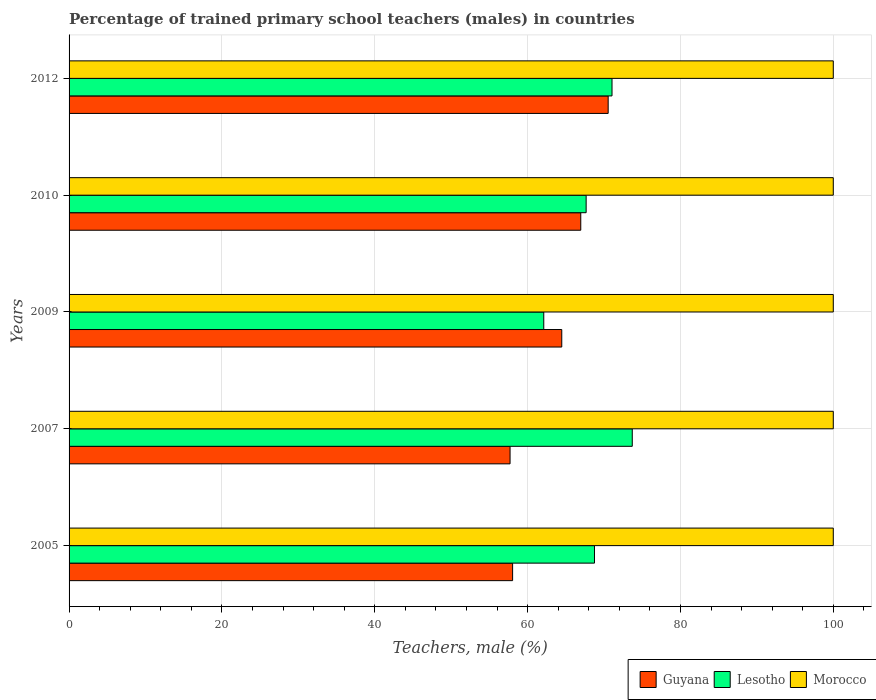How many groups of bars are there?
Give a very brief answer. 5. Are the number of bars per tick equal to the number of legend labels?
Your answer should be compact. Yes. What is the label of the 4th group of bars from the top?
Provide a succinct answer. 2007. In which year was the percentage of trained primary school teachers (males) in Morocco maximum?
Your answer should be very brief. 2005. What is the total percentage of trained primary school teachers (males) in Lesotho in the graph?
Your answer should be compact. 343.27. What is the difference between the percentage of trained primary school teachers (males) in Lesotho in 2005 and that in 2012?
Offer a very short reply. -2.29. What is the difference between the percentage of trained primary school teachers (males) in Guyana in 2010 and the percentage of trained primary school teachers (males) in Lesotho in 2009?
Your answer should be compact. 4.84. What is the average percentage of trained primary school teachers (males) in Lesotho per year?
Provide a short and direct response. 68.65. In the year 2009, what is the difference between the percentage of trained primary school teachers (males) in Morocco and percentage of trained primary school teachers (males) in Lesotho?
Your response must be concise. 37.88. What is the ratio of the percentage of trained primary school teachers (males) in Lesotho in 2007 to that in 2012?
Your answer should be very brief. 1.04. What is the difference between the highest and the second highest percentage of trained primary school teachers (males) in Guyana?
Give a very brief answer. 3.59. What is the difference between the highest and the lowest percentage of trained primary school teachers (males) in Guyana?
Give a very brief answer. 12.84. In how many years, is the percentage of trained primary school teachers (males) in Lesotho greater than the average percentage of trained primary school teachers (males) in Lesotho taken over all years?
Provide a short and direct response. 3. Is the sum of the percentage of trained primary school teachers (males) in Morocco in 2005 and 2012 greater than the maximum percentage of trained primary school teachers (males) in Guyana across all years?
Keep it short and to the point. Yes. What does the 1st bar from the top in 2007 represents?
Make the answer very short. Morocco. What does the 2nd bar from the bottom in 2010 represents?
Your answer should be very brief. Lesotho. Are all the bars in the graph horizontal?
Give a very brief answer. Yes. How many years are there in the graph?
Your answer should be very brief. 5. Does the graph contain any zero values?
Make the answer very short. No. How are the legend labels stacked?
Your answer should be very brief. Horizontal. What is the title of the graph?
Offer a terse response. Percentage of trained primary school teachers (males) in countries. What is the label or title of the X-axis?
Your answer should be compact. Teachers, male (%). What is the Teachers, male (%) in Guyana in 2005?
Offer a terse response. 58.04. What is the Teachers, male (%) in Lesotho in 2005?
Give a very brief answer. 68.75. What is the Teachers, male (%) in Morocco in 2005?
Your answer should be compact. 100. What is the Teachers, male (%) in Guyana in 2007?
Offer a terse response. 57.71. What is the Teachers, male (%) in Lesotho in 2007?
Ensure brevity in your answer.  73.7. What is the Teachers, male (%) of Guyana in 2009?
Offer a very short reply. 64.47. What is the Teachers, male (%) of Lesotho in 2009?
Ensure brevity in your answer.  62.12. What is the Teachers, male (%) of Guyana in 2010?
Your answer should be compact. 66.96. What is the Teachers, male (%) in Lesotho in 2010?
Make the answer very short. 67.66. What is the Teachers, male (%) of Guyana in 2012?
Provide a succinct answer. 70.54. What is the Teachers, male (%) of Lesotho in 2012?
Offer a very short reply. 71.05. Across all years, what is the maximum Teachers, male (%) in Guyana?
Provide a short and direct response. 70.54. Across all years, what is the maximum Teachers, male (%) in Lesotho?
Offer a very short reply. 73.7. Across all years, what is the minimum Teachers, male (%) in Guyana?
Your response must be concise. 57.71. Across all years, what is the minimum Teachers, male (%) in Lesotho?
Provide a succinct answer. 62.12. What is the total Teachers, male (%) in Guyana in the graph?
Your answer should be compact. 317.71. What is the total Teachers, male (%) in Lesotho in the graph?
Give a very brief answer. 343.27. What is the difference between the Teachers, male (%) of Guyana in 2005 and that in 2007?
Your response must be concise. 0.33. What is the difference between the Teachers, male (%) in Lesotho in 2005 and that in 2007?
Offer a very short reply. -4.94. What is the difference between the Teachers, male (%) of Guyana in 2005 and that in 2009?
Keep it short and to the point. -6.43. What is the difference between the Teachers, male (%) in Lesotho in 2005 and that in 2009?
Offer a very short reply. 6.64. What is the difference between the Teachers, male (%) in Guyana in 2005 and that in 2010?
Keep it short and to the point. -8.92. What is the difference between the Teachers, male (%) in Lesotho in 2005 and that in 2010?
Give a very brief answer. 1.09. What is the difference between the Teachers, male (%) of Morocco in 2005 and that in 2010?
Ensure brevity in your answer.  0. What is the difference between the Teachers, male (%) of Guyana in 2005 and that in 2012?
Keep it short and to the point. -12.5. What is the difference between the Teachers, male (%) of Lesotho in 2005 and that in 2012?
Give a very brief answer. -2.29. What is the difference between the Teachers, male (%) in Guyana in 2007 and that in 2009?
Offer a terse response. -6.76. What is the difference between the Teachers, male (%) of Lesotho in 2007 and that in 2009?
Offer a terse response. 11.58. What is the difference between the Teachers, male (%) in Morocco in 2007 and that in 2009?
Your response must be concise. 0. What is the difference between the Teachers, male (%) of Guyana in 2007 and that in 2010?
Make the answer very short. -9.25. What is the difference between the Teachers, male (%) in Lesotho in 2007 and that in 2010?
Provide a short and direct response. 6.04. What is the difference between the Teachers, male (%) of Morocco in 2007 and that in 2010?
Provide a short and direct response. 0. What is the difference between the Teachers, male (%) in Guyana in 2007 and that in 2012?
Ensure brevity in your answer.  -12.84. What is the difference between the Teachers, male (%) in Lesotho in 2007 and that in 2012?
Provide a short and direct response. 2.65. What is the difference between the Teachers, male (%) in Guyana in 2009 and that in 2010?
Make the answer very short. -2.49. What is the difference between the Teachers, male (%) in Lesotho in 2009 and that in 2010?
Provide a succinct answer. -5.54. What is the difference between the Teachers, male (%) of Morocco in 2009 and that in 2010?
Offer a very short reply. 0. What is the difference between the Teachers, male (%) in Guyana in 2009 and that in 2012?
Give a very brief answer. -6.07. What is the difference between the Teachers, male (%) of Lesotho in 2009 and that in 2012?
Give a very brief answer. -8.93. What is the difference between the Teachers, male (%) of Guyana in 2010 and that in 2012?
Your answer should be very brief. -3.59. What is the difference between the Teachers, male (%) of Lesotho in 2010 and that in 2012?
Give a very brief answer. -3.38. What is the difference between the Teachers, male (%) of Morocco in 2010 and that in 2012?
Your answer should be very brief. 0. What is the difference between the Teachers, male (%) of Guyana in 2005 and the Teachers, male (%) of Lesotho in 2007?
Provide a short and direct response. -15.66. What is the difference between the Teachers, male (%) in Guyana in 2005 and the Teachers, male (%) in Morocco in 2007?
Provide a short and direct response. -41.96. What is the difference between the Teachers, male (%) in Lesotho in 2005 and the Teachers, male (%) in Morocco in 2007?
Offer a terse response. -31.25. What is the difference between the Teachers, male (%) of Guyana in 2005 and the Teachers, male (%) of Lesotho in 2009?
Your answer should be very brief. -4.08. What is the difference between the Teachers, male (%) in Guyana in 2005 and the Teachers, male (%) in Morocco in 2009?
Offer a very short reply. -41.96. What is the difference between the Teachers, male (%) of Lesotho in 2005 and the Teachers, male (%) of Morocco in 2009?
Your response must be concise. -31.25. What is the difference between the Teachers, male (%) of Guyana in 2005 and the Teachers, male (%) of Lesotho in 2010?
Provide a short and direct response. -9.62. What is the difference between the Teachers, male (%) of Guyana in 2005 and the Teachers, male (%) of Morocco in 2010?
Offer a very short reply. -41.96. What is the difference between the Teachers, male (%) in Lesotho in 2005 and the Teachers, male (%) in Morocco in 2010?
Offer a terse response. -31.25. What is the difference between the Teachers, male (%) in Guyana in 2005 and the Teachers, male (%) in Lesotho in 2012?
Offer a terse response. -13.01. What is the difference between the Teachers, male (%) in Guyana in 2005 and the Teachers, male (%) in Morocco in 2012?
Offer a very short reply. -41.96. What is the difference between the Teachers, male (%) of Lesotho in 2005 and the Teachers, male (%) of Morocco in 2012?
Offer a very short reply. -31.25. What is the difference between the Teachers, male (%) in Guyana in 2007 and the Teachers, male (%) in Lesotho in 2009?
Offer a terse response. -4.41. What is the difference between the Teachers, male (%) of Guyana in 2007 and the Teachers, male (%) of Morocco in 2009?
Your response must be concise. -42.29. What is the difference between the Teachers, male (%) of Lesotho in 2007 and the Teachers, male (%) of Morocco in 2009?
Your answer should be very brief. -26.3. What is the difference between the Teachers, male (%) of Guyana in 2007 and the Teachers, male (%) of Lesotho in 2010?
Make the answer very short. -9.96. What is the difference between the Teachers, male (%) in Guyana in 2007 and the Teachers, male (%) in Morocco in 2010?
Your answer should be very brief. -42.29. What is the difference between the Teachers, male (%) of Lesotho in 2007 and the Teachers, male (%) of Morocco in 2010?
Provide a succinct answer. -26.3. What is the difference between the Teachers, male (%) in Guyana in 2007 and the Teachers, male (%) in Lesotho in 2012?
Provide a short and direct response. -13.34. What is the difference between the Teachers, male (%) in Guyana in 2007 and the Teachers, male (%) in Morocco in 2012?
Make the answer very short. -42.29. What is the difference between the Teachers, male (%) in Lesotho in 2007 and the Teachers, male (%) in Morocco in 2012?
Offer a very short reply. -26.3. What is the difference between the Teachers, male (%) in Guyana in 2009 and the Teachers, male (%) in Lesotho in 2010?
Give a very brief answer. -3.19. What is the difference between the Teachers, male (%) in Guyana in 2009 and the Teachers, male (%) in Morocco in 2010?
Give a very brief answer. -35.53. What is the difference between the Teachers, male (%) in Lesotho in 2009 and the Teachers, male (%) in Morocco in 2010?
Offer a terse response. -37.88. What is the difference between the Teachers, male (%) in Guyana in 2009 and the Teachers, male (%) in Lesotho in 2012?
Offer a terse response. -6.57. What is the difference between the Teachers, male (%) in Guyana in 2009 and the Teachers, male (%) in Morocco in 2012?
Provide a short and direct response. -35.53. What is the difference between the Teachers, male (%) in Lesotho in 2009 and the Teachers, male (%) in Morocco in 2012?
Your answer should be compact. -37.88. What is the difference between the Teachers, male (%) of Guyana in 2010 and the Teachers, male (%) of Lesotho in 2012?
Give a very brief answer. -4.09. What is the difference between the Teachers, male (%) in Guyana in 2010 and the Teachers, male (%) in Morocco in 2012?
Ensure brevity in your answer.  -33.04. What is the difference between the Teachers, male (%) in Lesotho in 2010 and the Teachers, male (%) in Morocco in 2012?
Provide a short and direct response. -32.34. What is the average Teachers, male (%) of Guyana per year?
Provide a succinct answer. 63.54. What is the average Teachers, male (%) of Lesotho per year?
Provide a short and direct response. 68.65. What is the average Teachers, male (%) of Morocco per year?
Offer a terse response. 100. In the year 2005, what is the difference between the Teachers, male (%) in Guyana and Teachers, male (%) in Lesotho?
Your response must be concise. -10.71. In the year 2005, what is the difference between the Teachers, male (%) of Guyana and Teachers, male (%) of Morocco?
Your answer should be compact. -41.96. In the year 2005, what is the difference between the Teachers, male (%) in Lesotho and Teachers, male (%) in Morocco?
Your response must be concise. -31.25. In the year 2007, what is the difference between the Teachers, male (%) of Guyana and Teachers, male (%) of Lesotho?
Your answer should be very brief. -15.99. In the year 2007, what is the difference between the Teachers, male (%) of Guyana and Teachers, male (%) of Morocco?
Your answer should be compact. -42.29. In the year 2007, what is the difference between the Teachers, male (%) in Lesotho and Teachers, male (%) in Morocco?
Your answer should be compact. -26.3. In the year 2009, what is the difference between the Teachers, male (%) in Guyana and Teachers, male (%) in Lesotho?
Give a very brief answer. 2.35. In the year 2009, what is the difference between the Teachers, male (%) in Guyana and Teachers, male (%) in Morocco?
Ensure brevity in your answer.  -35.53. In the year 2009, what is the difference between the Teachers, male (%) of Lesotho and Teachers, male (%) of Morocco?
Your answer should be compact. -37.88. In the year 2010, what is the difference between the Teachers, male (%) in Guyana and Teachers, male (%) in Lesotho?
Your response must be concise. -0.71. In the year 2010, what is the difference between the Teachers, male (%) of Guyana and Teachers, male (%) of Morocco?
Your response must be concise. -33.04. In the year 2010, what is the difference between the Teachers, male (%) in Lesotho and Teachers, male (%) in Morocco?
Ensure brevity in your answer.  -32.34. In the year 2012, what is the difference between the Teachers, male (%) of Guyana and Teachers, male (%) of Lesotho?
Keep it short and to the point. -0.5. In the year 2012, what is the difference between the Teachers, male (%) in Guyana and Teachers, male (%) in Morocco?
Give a very brief answer. -29.46. In the year 2012, what is the difference between the Teachers, male (%) in Lesotho and Teachers, male (%) in Morocco?
Provide a succinct answer. -28.95. What is the ratio of the Teachers, male (%) of Lesotho in 2005 to that in 2007?
Give a very brief answer. 0.93. What is the ratio of the Teachers, male (%) of Morocco in 2005 to that in 2007?
Your answer should be very brief. 1. What is the ratio of the Teachers, male (%) in Guyana in 2005 to that in 2009?
Your answer should be very brief. 0.9. What is the ratio of the Teachers, male (%) of Lesotho in 2005 to that in 2009?
Provide a short and direct response. 1.11. What is the ratio of the Teachers, male (%) in Guyana in 2005 to that in 2010?
Keep it short and to the point. 0.87. What is the ratio of the Teachers, male (%) of Lesotho in 2005 to that in 2010?
Your response must be concise. 1.02. What is the ratio of the Teachers, male (%) of Guyana in 2005 to that in 2012?
Offer a terse response. 0.82. What is the ratio of the Teachers, male (%) of Lesotho in 2005 to that in 2012?
Your answer should be very brief. 0.97. What is the ratio of the Teachers, male (%) of Guyana in 2007 to that in 2009?
Your answer should be compact. 0.9. What is the ratio of the Teachers, male (%) of Lesotho in 2007 to that in 2009?
Ensure brevity in your answer.  1.19. What is the ratio of the Teachers, male (%) in Morocco in 2007 to that in 2009?
Give a very brief answer. 1. What is the ratio of the Teachers, male (%) in Guyana in 2007 to that in 2010?
Provide a short and direct response. 0.86. What is the ratio of the Teachers, male (%) of Lesotho in 2007 to that in 2010?
Your response must be concise. 1.09. What is the ratio of the Teachers, male (%) of Morocco in 2007 to that in 2010?
Keep it short and to the point. 1. What is the ratio of the Teachers, male (%) of Guyana in 2007 to that in 2012?
Your response must be concise. 0.82. What is the ratio of the Teachers, male (%) in Lesotho in 2007 to that in 2012?
Provide a short and direct response. 1.04. What is the ratio of the Teachers, male (%) in Guyana in 2009 to that in 2010?
Offer a very short reply. 0.96. What is the ratio of the Teachers, male (%) of Lesotho in 2009 to that in 2010?
Keep it short and to the point. 0.92. What is the ratio of the Teachers, male (%) in Guyana in 2009 to that in 2012?
Offer a terse response. 0.91. What is the ratio of the Teachers, male (%) in Lesotho in 2009 to that in 2012?
Your response must be concise. 0.87. What is the ratio of the Teachers, male (%) of Morocco in 2009 to that in 2012?
Provide a succinct answer. 1. What is the ratio of the Teachers, male (%) in Guyana in 2010 to that in 2012?
Make the answer very short. 0.95. What is the ratio of the Teachers, male (%) of Morocco in 2010 to that in 2012?
Offer a terse response. 1. What is the difference between the highest and the second highest Teachers, male (%) of Guyana?
Give a very brief answer. 3.59. What is the difference between the highest and the second highest Teachers, male (%) in Lesotho?
Make the answer very short. 2.65. What is the difference between the highest and the second highest Teachers, male (%) in Morocco?
Offer a terse response. 0. What is the difference between the highest and the lowest Teachers, male (%) in Guyana?
Your answer should be compact. 12.84. What is the difference between the highest and the lowest Teachers, male (%) of Lesotho?
Your response must be concise. 11.58. 